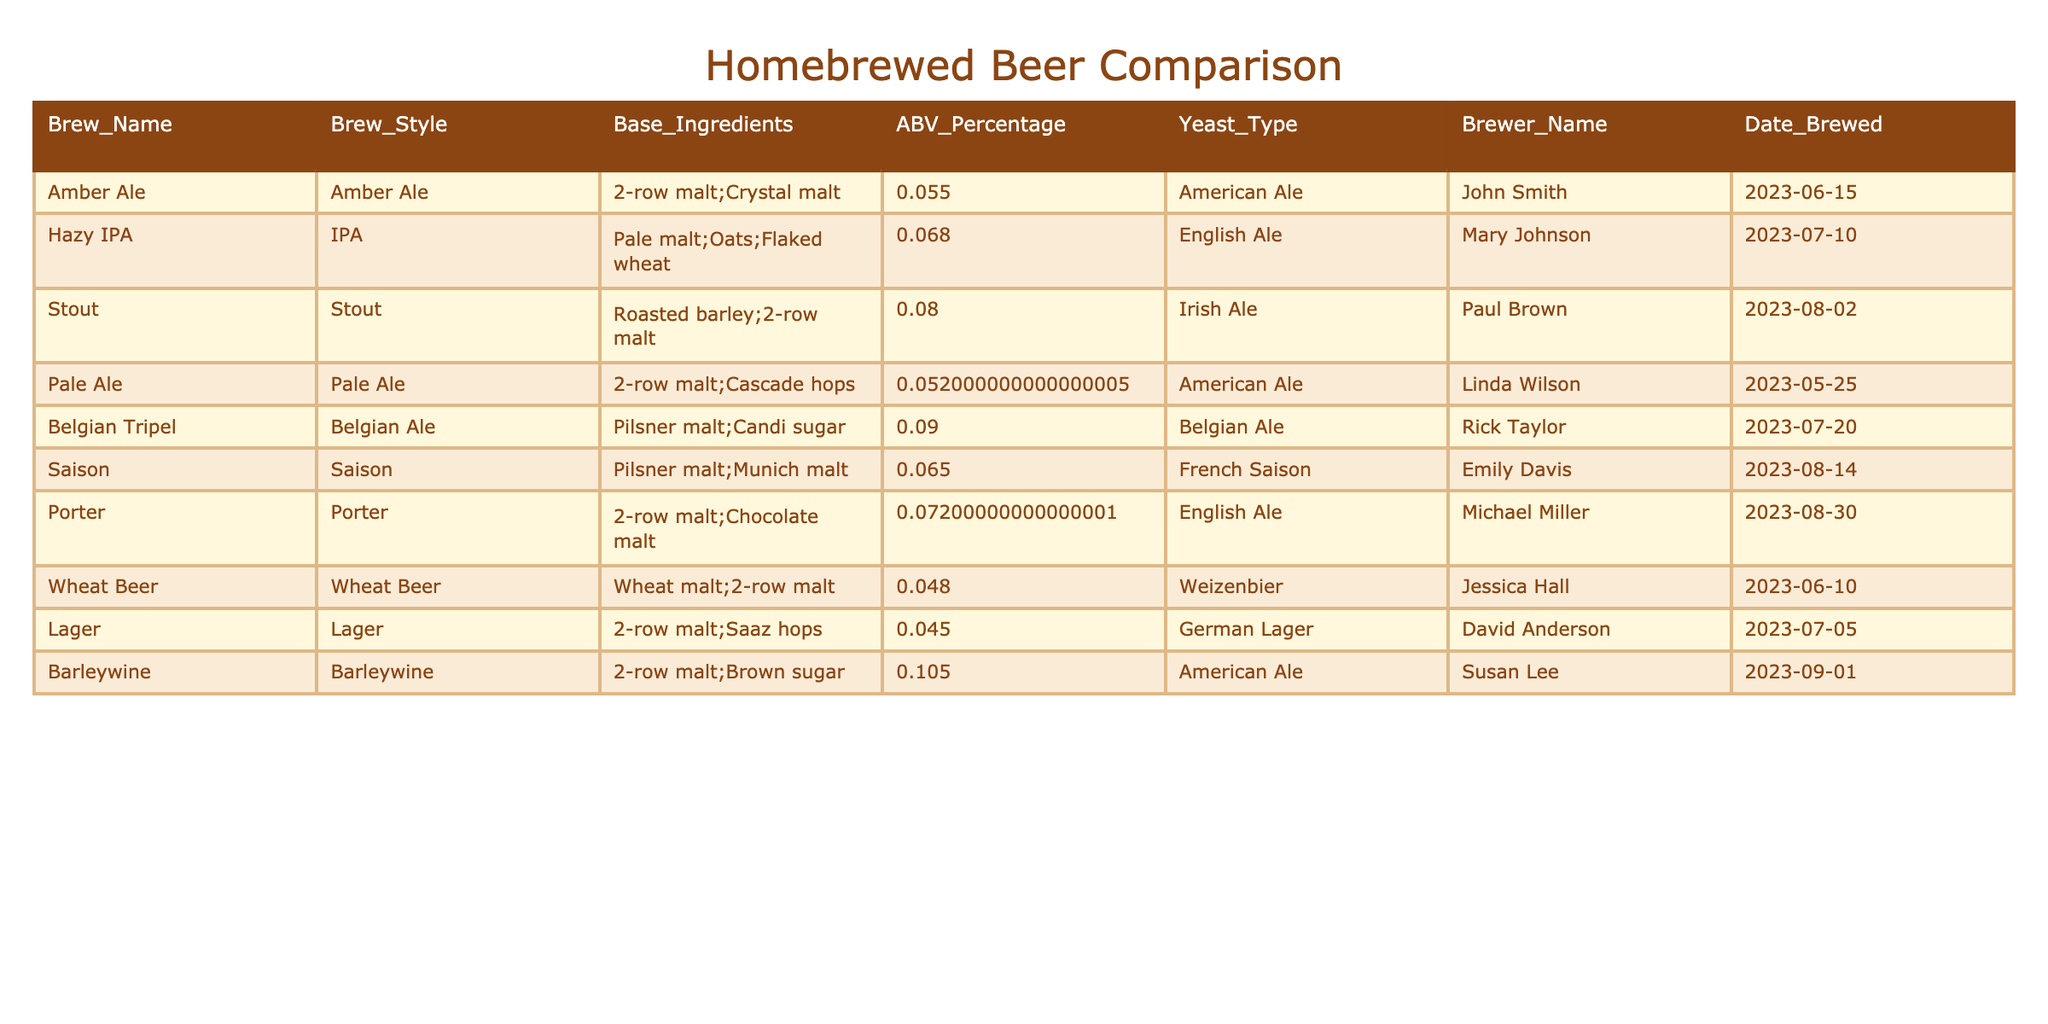What is the ABV percentage of the Hazy IPA? The table lists the ABV percentage for the Hazy IPA, which is stated as 6.8%.
Answer: 6.8% Which brew style has the highest ABV? By examining the ABV percentages listed in the table, the Belgian Tripel has the highest ABV at 9.0%.
Answer: Belgian Tripel Is there a brew called "Porter" in the table? Looking through the Brew_Name column, "Porter" is indeed listed.
Answer: Yes What is the average ABV of the beers with an ABV over 6.0%? First, identify the beers with ABV over 6.0%: Hazy IPA (6.8%), Stout (8.0%), Belgian Tripel (9.0%), Saison (6.5%), and Porter (7.2%). Their total is 37.5% (6.8 + 8.0 + 9.0 + 6.5 + 7.2), and there are 5 beers, so the average is 37.5% / 5 = 7.5%.
Answer: 7.5% What proportion of the brews use American Ale yeast? The table shows two brews, Amber Ale and Barleywine, use American Ale yeast out of a total of 10 brews; thus, the proportion is 2 out of 10, or 20%.
Answer: 20% How many different yeast types are used in the table? By checking the Yeast_Type column, the unique yeast types listed are: American Ale, English Ale, Irish Ale, Belgian Ale, French Saison, and Weizenbier, totaling 6 distinct yeast types.
Answer: 6 Which brew was made by Susan Lee? The table specifies that the Barleywine was brewed by Susan Lee.
Answer: Barleywine What is the difference between the ABV of the Belgian Tripel and the Wheat Beer? The ABV for Belgian Tripel is 9.0% and for Wheat Beer is 4.8%, so the difference is 9.0% - 4.8% = 4.2%.
Answer: 4.2% Is there a beer with an ABV percentage below 5%? Examining the ABV percentages, Lager has an ABV of 4.5% and Wheat Beer has an ABV of 4.8%, indicating that yes, there are beers below 5%.
Answer: Yes What is the total ABV percentage of all beers brewed by John Smith? John Smith's brew is Amber Ale, which has an ABV percentage of 5.5%. Thus, the total ABV for John Smith is simply 5.5%.
Answer: 5.5% Which brew was brewed most recently? The most recently brewed beer listed is Barleywine, dated 2023-09-01, which can be confirmed by reviewing the Date_Brewed column.
Answer: Barleywine 